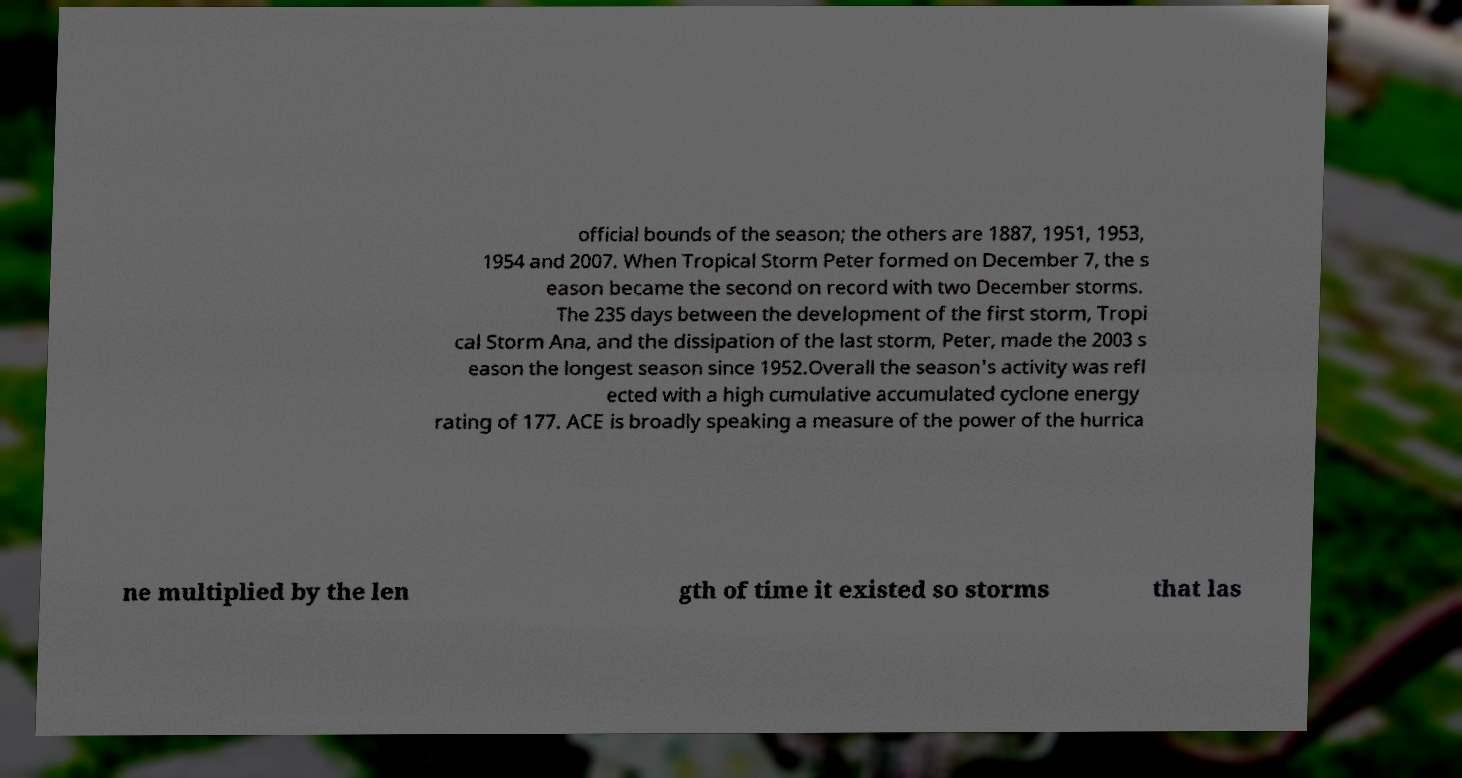For documentation purposes, I need the text within this image transcribed. Could you provide that? official bounds of the season; the others are 1887, 1951, 1953, 1954 and 2007. When Tropical Storm Peter formed on December 7, the s eason became the second on record with two December storms. The 235 days between the development of the first storm, Tropi cal Storm Ana, and the dissipation of the last storm, Peter, made the 2003 s eason the longest season since 1952.Overall the season's activity was refl ected with a high cumulative accumulated cyclone energy rating of 177. ACE is broadly speaking a measure of the power of the hurrica ne multiplied by the len gth of time it existed so storms that las 